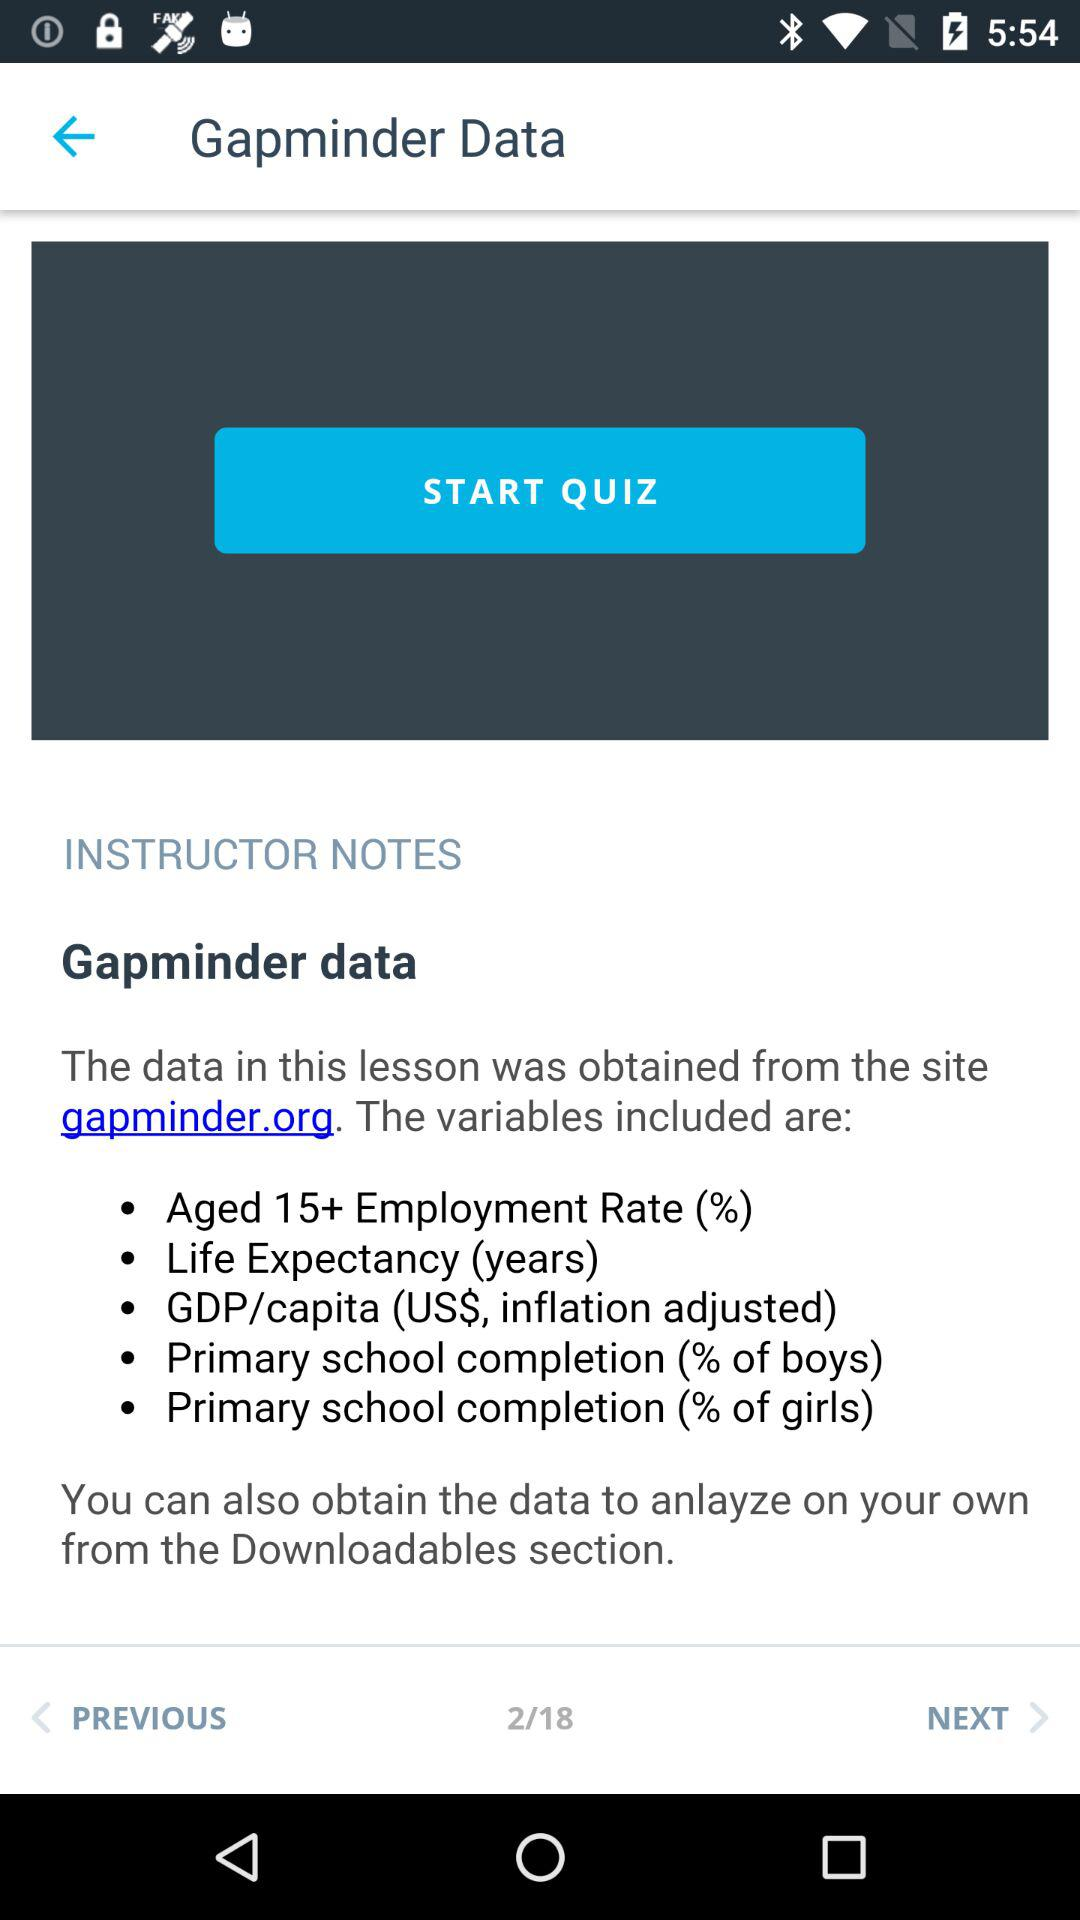At which instruction am I? You are at instruction number 2. 